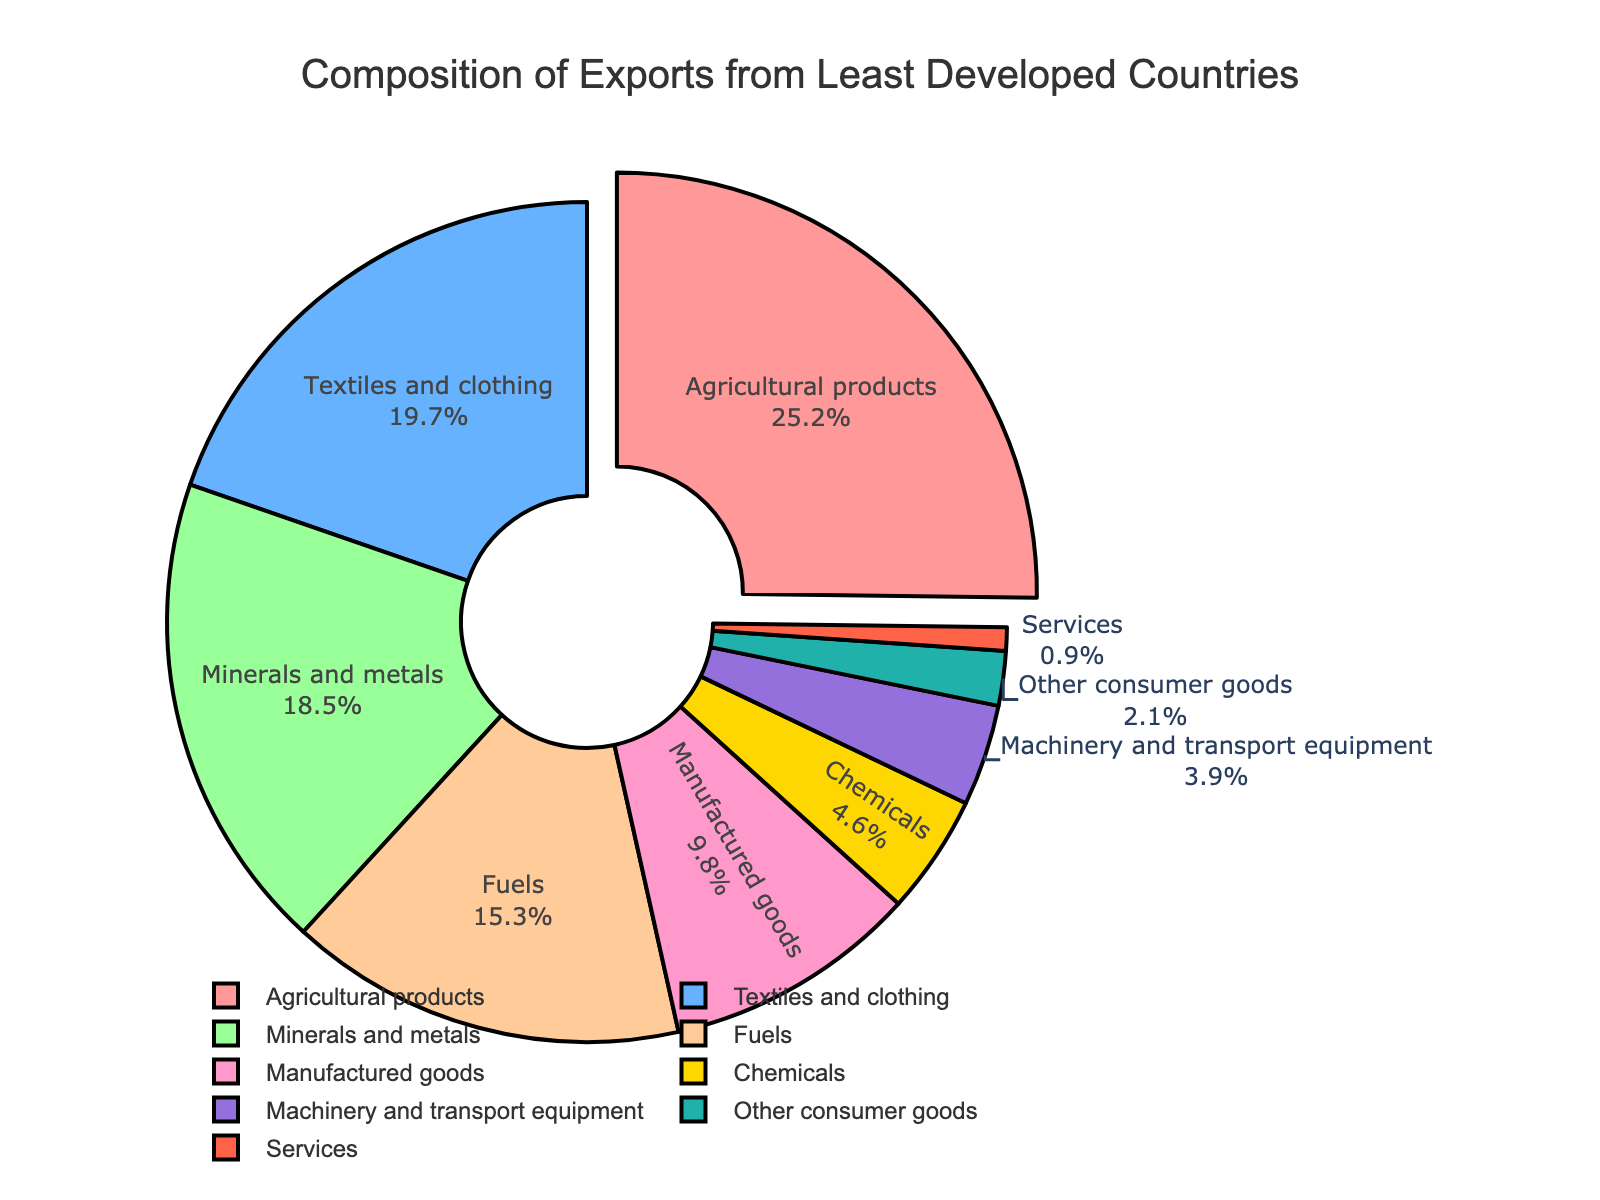Which category constitutes the highest percentage of exports? The pie chart shows different product categories and their corresponding percentages. Agricultural products have the largest slice pulled out from the chart, indicating it is the highest.
Answer: Agricultural products What is the total percentage of exports for Agricultural products, Textiles and clothing, and Minerals and metals combined? Adding the percentages of Agricultural products (25.2%), Textiles and clothing (19.7%), and Minerals and metals (18.5%) gives 25.2 + 19.7 + 18.5 = 63.4%.
Answer: 63.4% Which category has the smallest percentage share in exports? By looking at the pie chart, we can see that Services have the smallest slice.
Answer: Services Are the percentages of Fuels exports greater than Chemicals and Machinery and transport equipment combined? Fuels account for 15.3%. Chemicals and Machinery and transport equipment account for a total of 4.6 + 3.9 = 8.5%. Since 15.3% > 8.5%, Fuels exports' percentage is greater.
Answer: Yes What is the combined percentage of exports for all categories except Agricultural products and Textiles and clothing? Subtracting the percentages of Agricultural products (25.2%) and Textiles and clothing (19.7%) from 100% gives 100 - 25.2 - 19.7 = 55.1%.
Answer: 55.1% How much larger is the percentage of Agricultural products compared to Manufactured goods? The percentage for Agricultural products is 25.2%, and for Manufactured goods is 9.8%. The difference is 25.2 - 9.8 = 15.4%.
Answer: 15.4% What is the average percentage of exports for the categories Fuels, Chemicals, and Services? Adding the percentages for Fuels (15.3%), Chemicals (4.6%), and Services (0.9%) gives 20.8%. The average is 20.8 / 3 ≈ 6.93%.
Answer: 6.93% Which category is represented by the light blue slice in the pie chart? The light blue slice is the second largest and corresponds to Textiles and clothing, indicating it is the category represented by the light blue slice.
Answer: Textiles and clothing What is the percentage difference between the highest and lowest categories in the pie chart? The highest category is Agricultural products at 25.2%, and the lowest is Services at 0.9%. The difference is 25.2 - 0.9 = 24.3%.
Answer: 24.3% 